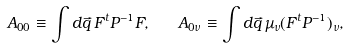<formula> <loc_0><loc_0><loc_500><loc_500>A _ { 0 0 } \equiv \int d \vec { q } \, F ^ { t } P ^ { - 1 } F , \quad A _ { 0 { \nu } } \equiv \int d \vec { q } \, \mu _ { \nu } ( F ^ { t } P ^ { - 1 } ) _ { \nu } ,</formula> 